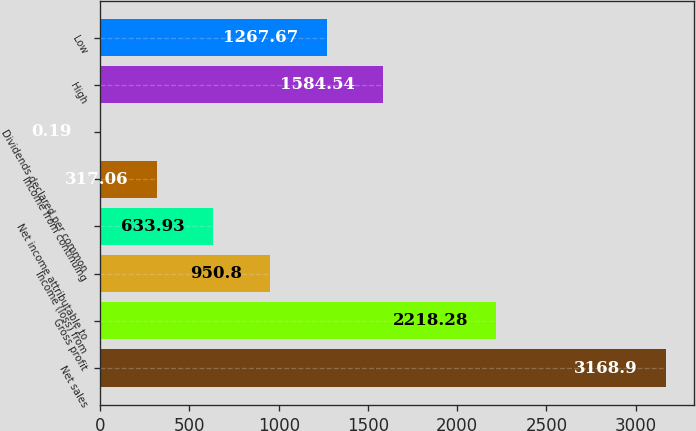Convert chart. <chart><loc_0><loc_0><loc_500><loc_500><bar_chart><fcel>Net sales<fcel>Gross profit<fcel>Income (loss) from<fcel>Net income attributable to<fcel>Income from continuing<fcel>Dividends declared per common<fcel>High<fcel>Low<nl><fcel>3168.9<fcel>2218.28<fcel>950.8<fcel>633.93<fcel>317.06<fcel>0.19<fcel>1584.54<fcel>1267.67<nl></chart> 